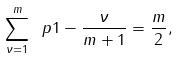<formula> <loc_0><loc_0><loc_500><loc_500>\sum _ { \nu = 1 } ^ { m } \ p { 1 - \frac { \nu } { m + 1 } } = \frac { m } { 2 } ,</formula> 